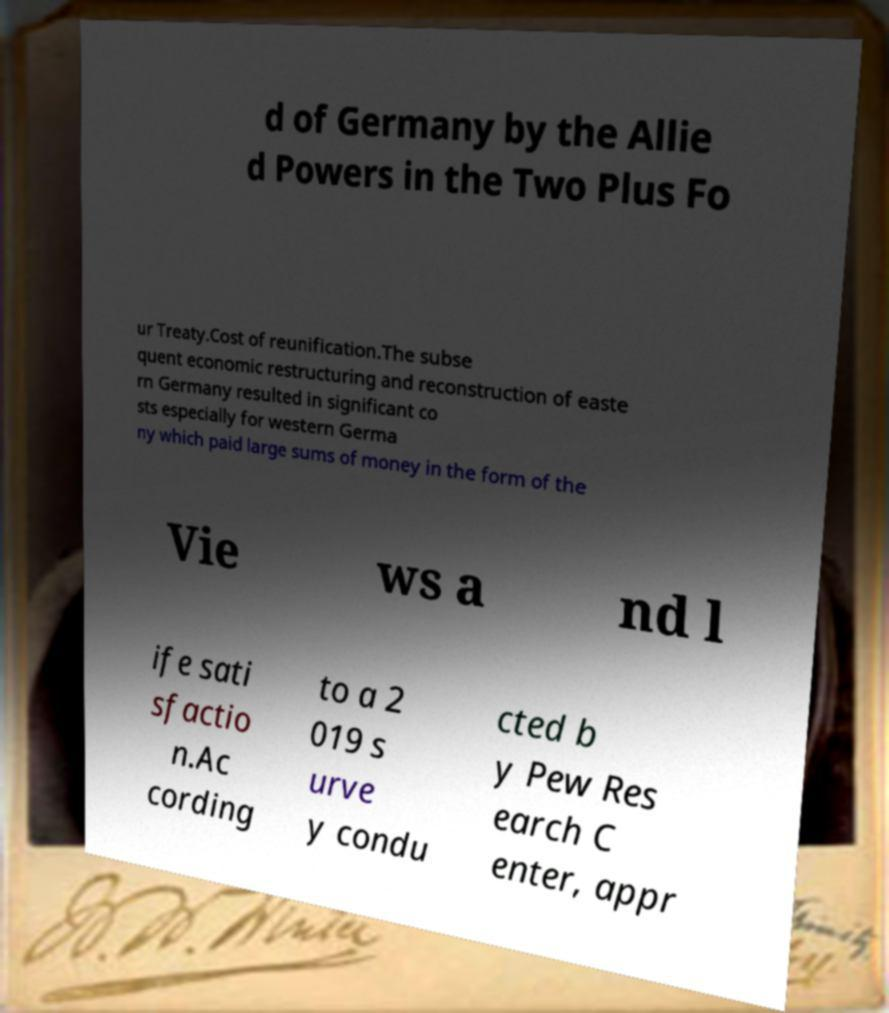Please read and relay the text visible in this image. What does it say? d of Germany by the Allie d Powers in the Two Plus Fo ur Treaty.Cost of reunification.The subse quent economic restructuring and reconstruction of easte rn Germany resulted in significant co sts especially for western Germa ny which paid large sums of money in the form of the Vie ws a nd l ife sati sfactio n.Ac cording to a 2 019 s urve y condu cted b y Pew Res earch C enter, appr 